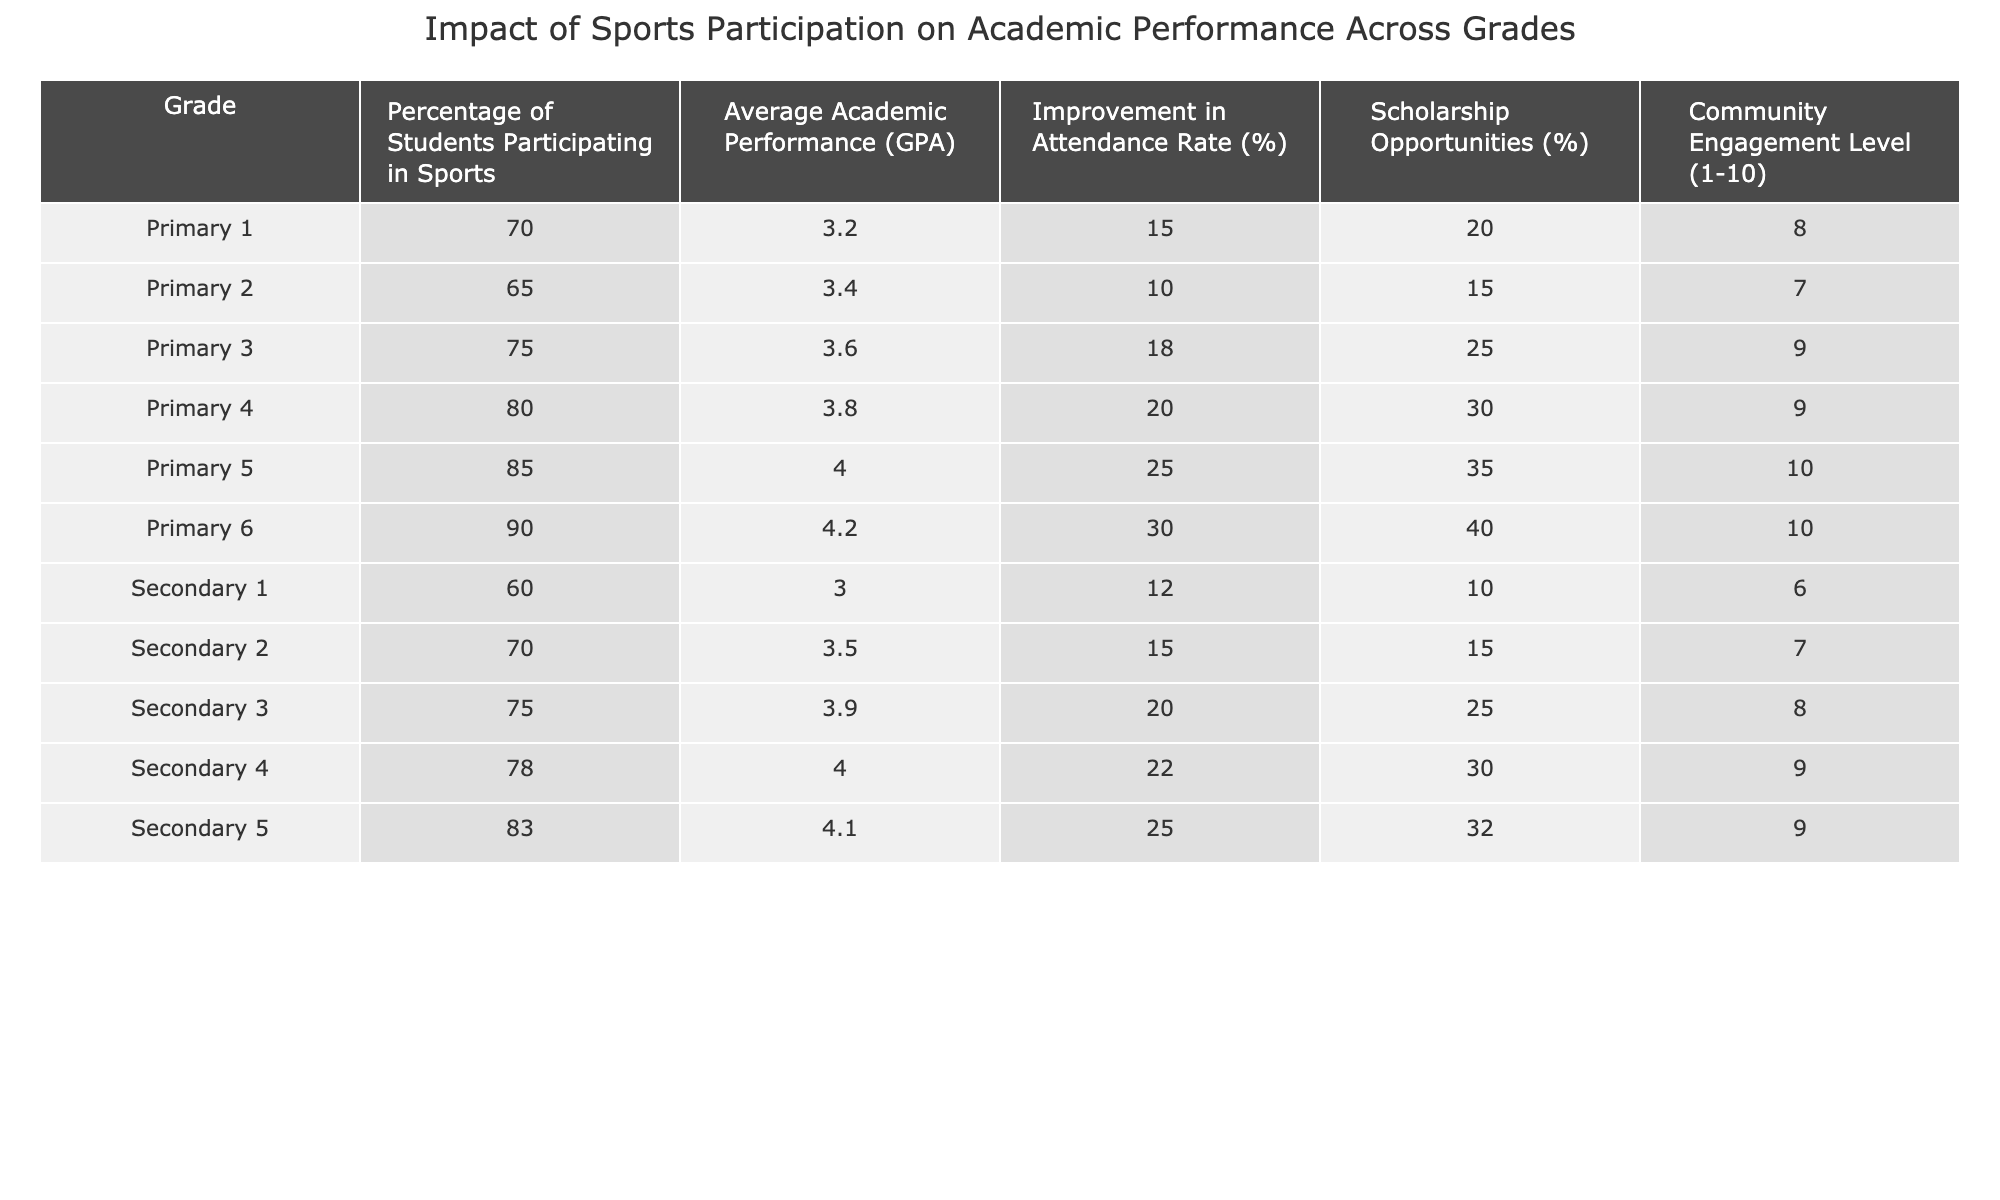What percentage of Primary 6 students participate in sports? According to the table, the percentage of students participating in sports for Primary 6 is explicitly listed as 90%.
Answer: 90% What is the average academic performance for Secondary 3 students? The table indicates that the average academic performance (GPA) for Secondary 3 students is 3.9.
Answer: 3.9 Which grade has the highest improvement in attendance rate? By examining the table, Primary 6 shows the highest improvement in attendance rate at 30%.
Answer: Primary 6 Is it true that Primary 5 students have a higher average GPA than Primary 4 students? The table lists Primary 5's average GPA as 4.0 and Primary 4's as 3.8, confirming that Primary 5 has a higher GPA.
Answer: Yes What is the difference in scholarship opportunities between Primary 5 and Secondary 5? Primary 5 has 35% scholarship opportunities and Secondary 5 has 32%, so the difference is 35% - 32% = 3%.
Answer: 3% Which grade has the lowest community engagement level? The table shows that Secondary 1 has the lowest community engagement level at 6 on the scale of 1 to 10.
Answer: Secondary 1 What is the average GPA for all Primary grades combined? To find the average GPA for Primary grades, sum the GPAs (3.2, 3.4, 3.6, 3.8, 4.0, 4.2) which totals 18.2. There are 6 grades, so the average is 18.2 / 6 = 3.03.
Answer: 3.03 If a student's attendance improved by 25%, what grade is that most likely to correspond to? The attendance improvement of 25% corresponds to Primary 5, according to the data.
Answer: Primary 5 How does the participation rate in sports for Secondary 1 compare to Secondary 2? The table shows that Secondary 1 has a participation rate of 60%, while Secondary 2 has a higher rate of 70%, indicating that Secondary 2's rate is greater.
Answer: Secondary 2 Which grade has both the lowest GPA and the lowest percentage of students participating in sports? Upon examining the table, Secondary 1 has the lowest GPA of 3.0 and also the lowest participation rate at 60%.
Answer: Secondary 1 